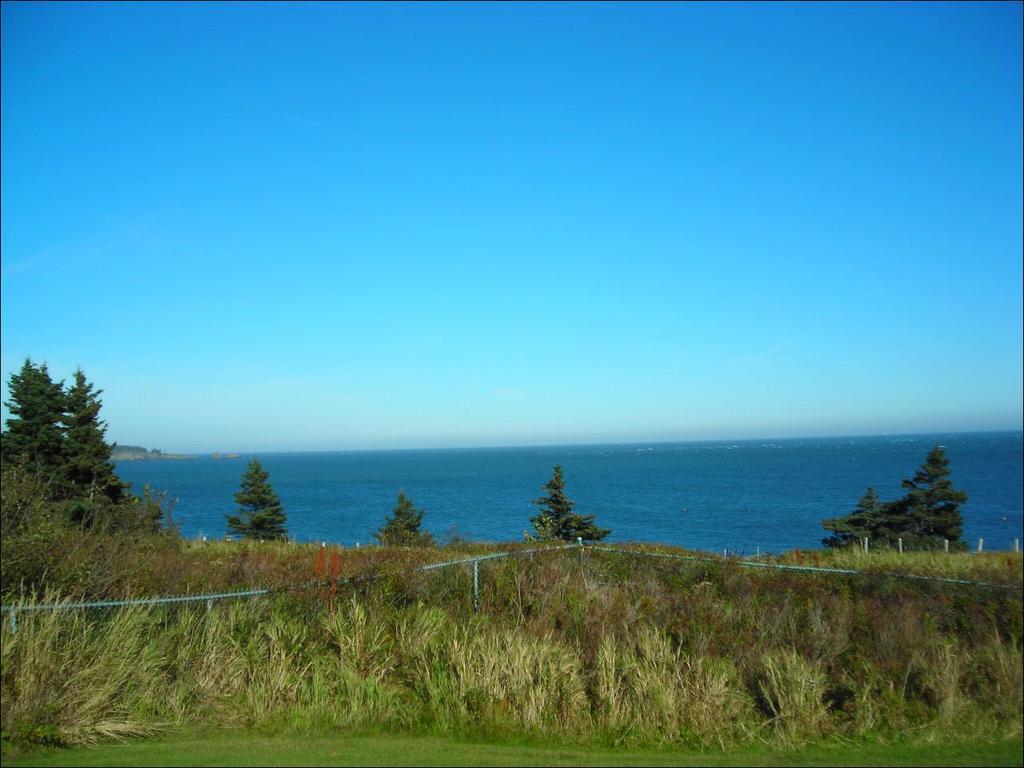How would you summarize this image in a sentence or two? As we can see in the image there is grass, plants, trees and water. On the top there is sky. 